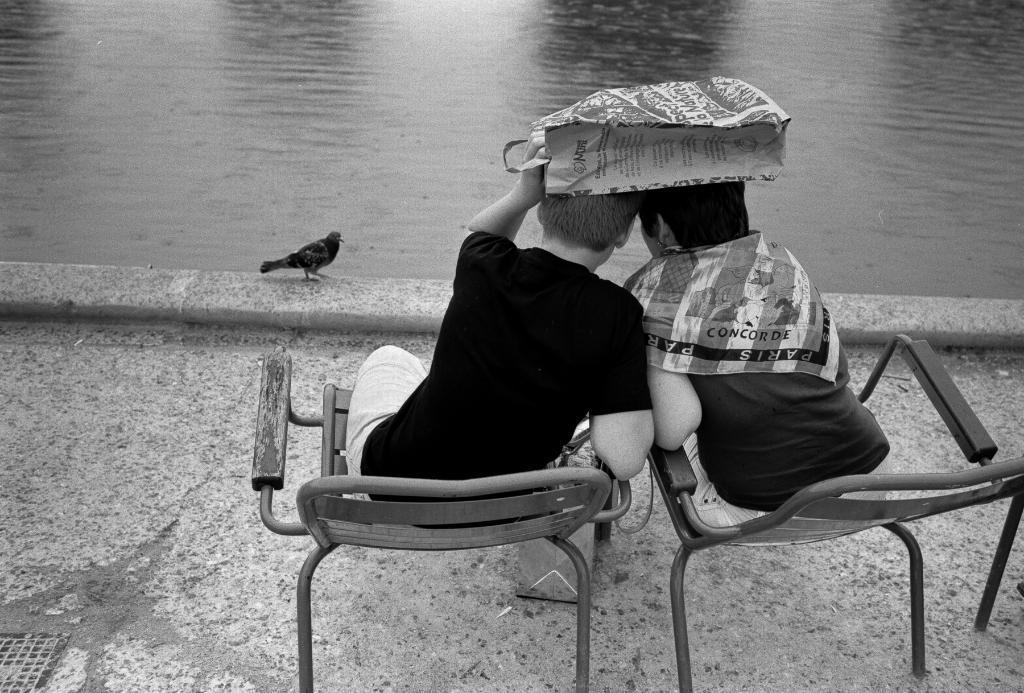Could you give a brief overview of what you see in this image? In the picture we can see a boy and a person sitting on a chairs, a boy is holding a bag on his head, he is with the black T-shirt, in the front of them there is a water, on the path there is a bird. 